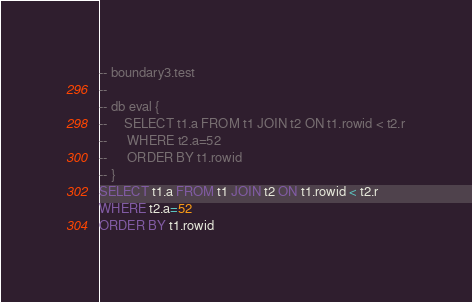<code> <loc_0><loc_0><loc_500><loc_500><_SQL_>-- boundary3.test
-- 
-- db eval {
--     SELECT t1.a FROM t1 JOIN t2 ON t1.rowid < t2.r
--      WHERE t2.a=52
--      ORDER BY t1.rowid
-- }
SELECT t1.a FROM t1 JOIN t2 ON t1.rowid < t2.r
WHERE t2.a=52
ORDER BY t1.rowid</code> 